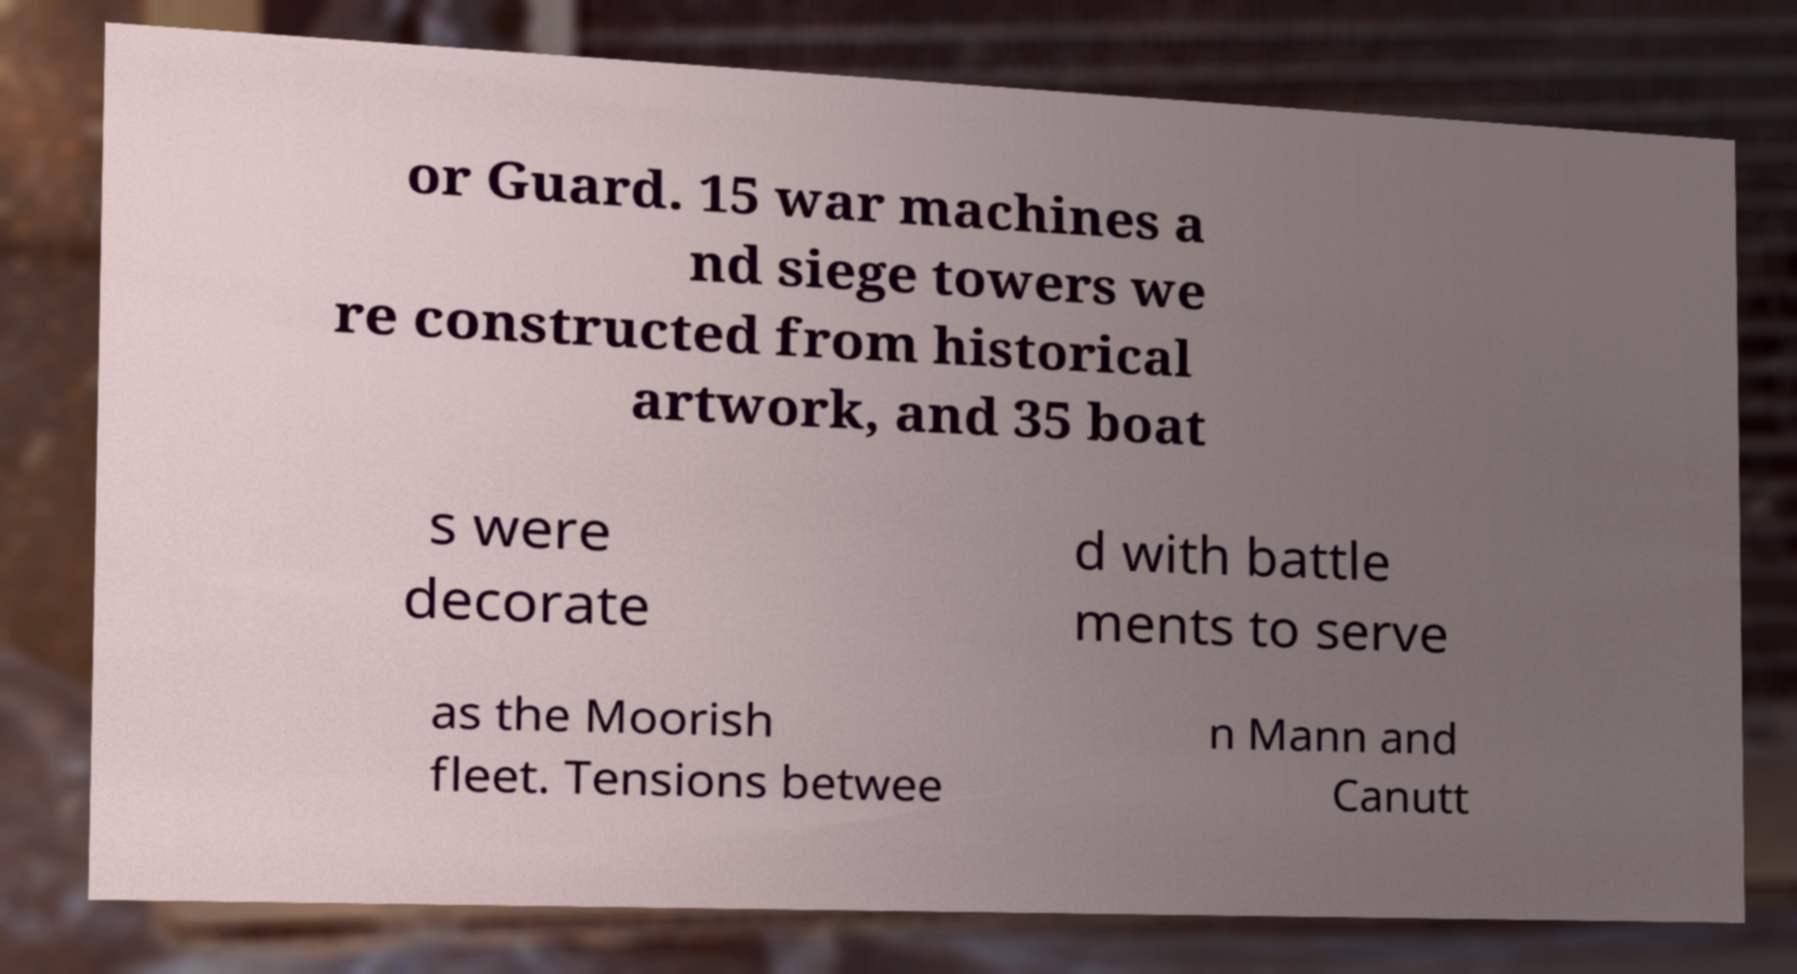Can you accurately transcribe the text from the provided image for me? or Guard. 15 war machines a nd siege towers we re constructed from historical artwork, and 35 boat s were decorate d with battle ments to serve as the Moorish fleet. Tensions betwee n Mann and Canutt 